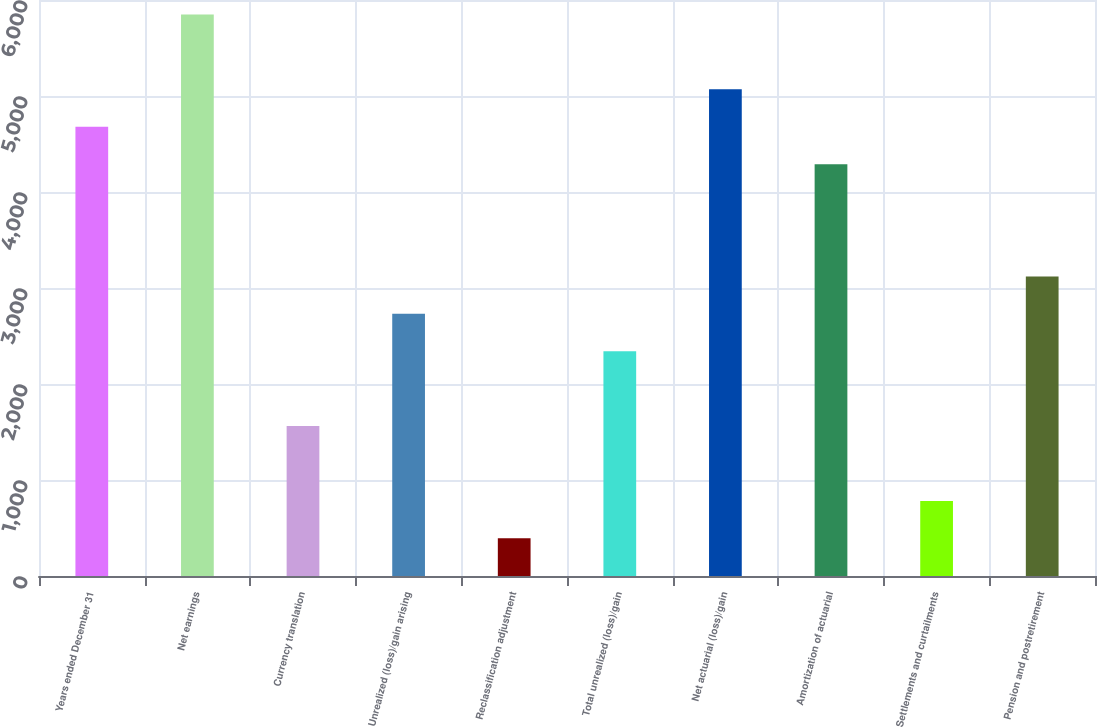Convert chart. <chart><loc_0><loc_0><loc_500><loc_500><bar_chart><fcel>Years ended December 31<fcel>Net earnings<fcel>Currency translation<fcel>Unrealized (loss)/gain arising<fcel>Reclassification adjustment<fcel>Total unrealized (loss)/gain<fcel>Net actuarial (loss)/gain<fcel>Amortization of actuarial<fcel>Settlements and curtailments<fcel>Pension and postretirement<nl><fcel>4679.4<fcel>5848.5<fcel>1561.8<fcel>2730.9<fcel>392.7<fcel>2341.2<fcel>5069.1<fcel>4289.7<fcel>782.4<fcel>3120.6<nl></chart> 